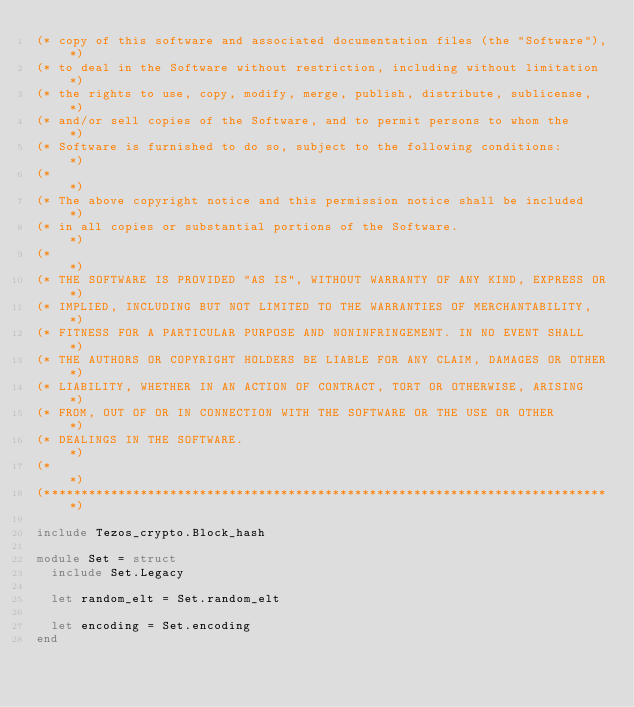Convert code to text. <code><loc_0><loc_0><loc_500><loc_500><_OCaml_>(* copy of this software and associated documentation files (the "Software"),*)
(* to deal in the Software without restriction, including without limitation *)
(* the rights to use, copy, modify, merge, publish, distribute, sublicense,  *)
(* and/or sell copies of the Software, and to permit persons to whom the     *)
(* Software is furnished to do so, subject to the following conditions:      *)
(*                                                                           *)
(* The above copyright notice and this permission notice shall be included   *)
(* in all copies or substantial portions of the Software.                    *)
(*                                                                           *)
(* THE SOFTWARE IS PROVIDED "AS IS", WITHOUT WARRANTY OF ANY KIND, EXPRESS OR*)
(* IMPLIED, INCLUDING BUT NOT LIMITED TO THE WARRANTIES OF MERCHANTABILITY,  *)
(* FITNESS FOR A PARTICULAR PURPOSE AND NONINFRINGEMENT. IN NO EVENT SHALL   *)
(* THE AUTHORS OR COPYRIGHT HOLDERS BE LIABLE FOR ANY CLAIM, DAMAGES OR OTHER*)
(* LIABILITY, WHETHER IN AN ACTION OF CONTRACT, TORT OR OTHERWISE, ARISING   *)
(* FROM, OUT OF OR IN CONNECTION WITH THE SOFTWARE OR THE USE OR OTHER       *)
(* DEALINGS IN THE SOFTWARE.                                                 *)
(*                                                                           *)
(*****************************************************************************)

include Tezos_crypto.Block_hash

module Set = struct
  include Set.Legacy

  let random_elt = Set.random_elt

  let encoding = Set.encoding
end
</code> 